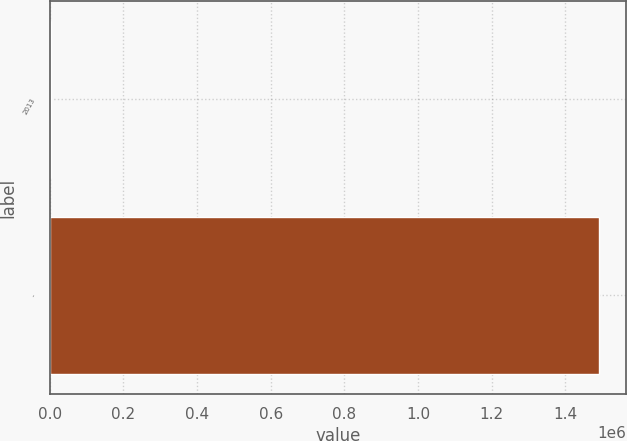Convert chart. <chart><loc_0><loc_0><loc_500><loc_500><bar_chart><fcel>2013<fcel>-<nl><fcel>2011<fcel>1.49073e+06<nl></chart> 